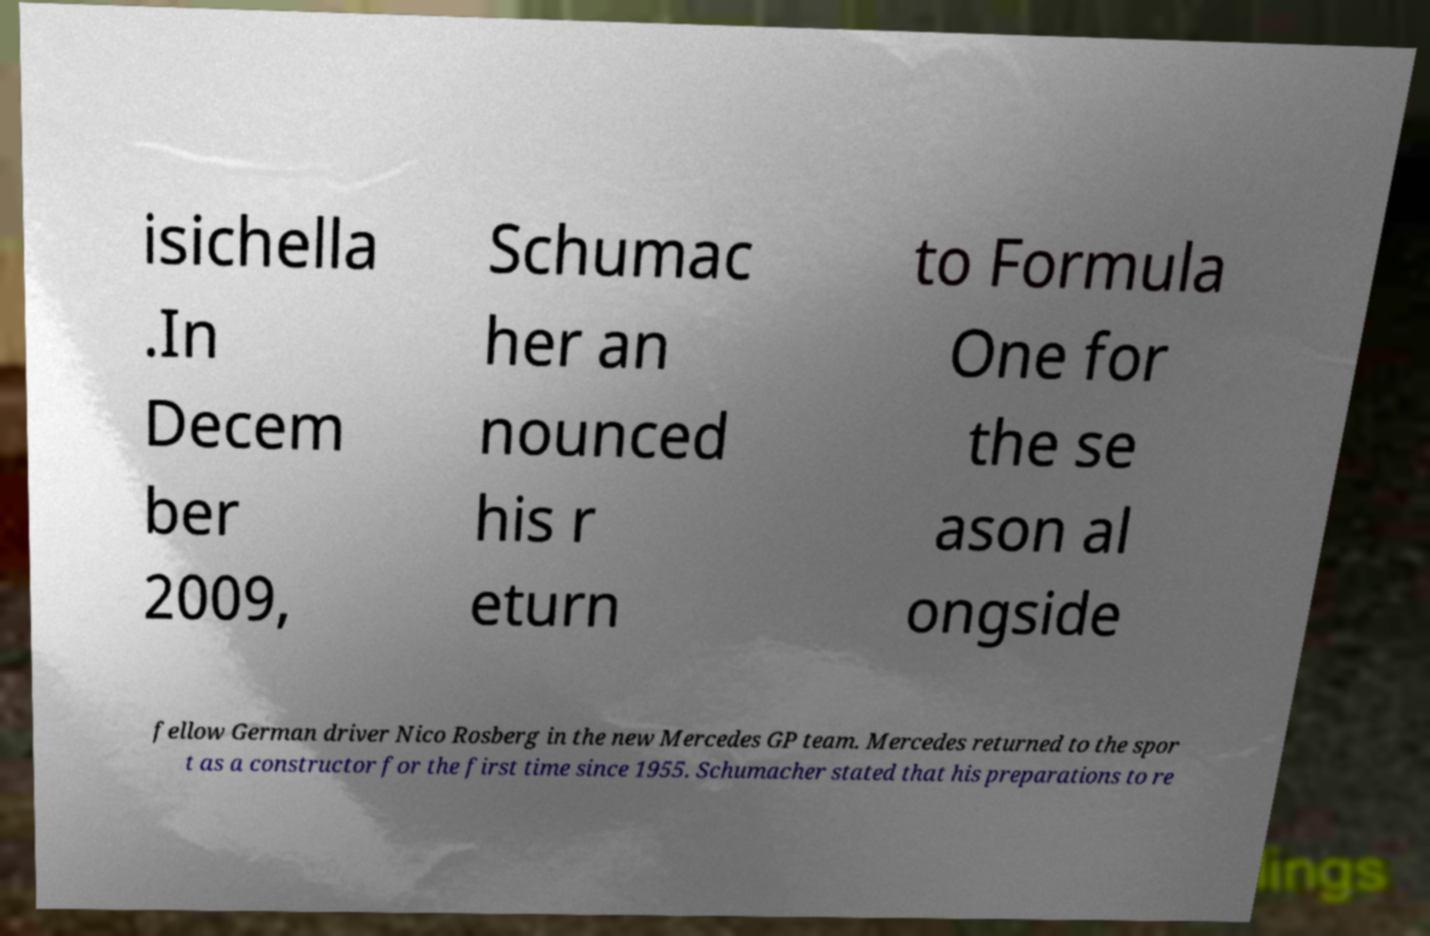Please read and relay the text visible in this image. What does it say? isichella .In Decem ber 2009, Schumac her an nounced his r eturn to Formula One for the se ason al ongside fellow German driver Nico Rosberg in the new Mercedes GP team. Mercedes returned to the spor t as a constructor for the first time since 1955. Schumacher stated that his preparations to re 